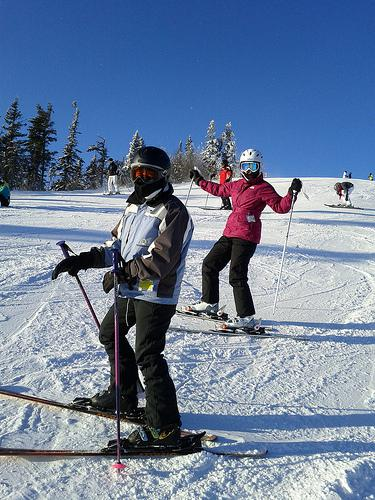Question: where was the photo taken?
Choices:
A. On a ski slope.
B. At skate park.
C. At the beach.
D. At the race track.
Answer with the letter. Answer: A Question: what color is the sky?
Choices:
A. White.
B. Blue.
C. Grey.
D. Black.
Answer with the letter. Answer: B Question: who is in the photo?
Choices:
A. People.
B. No one.
C. Children.
D. Students.
Answer with the letter. Answer: A 